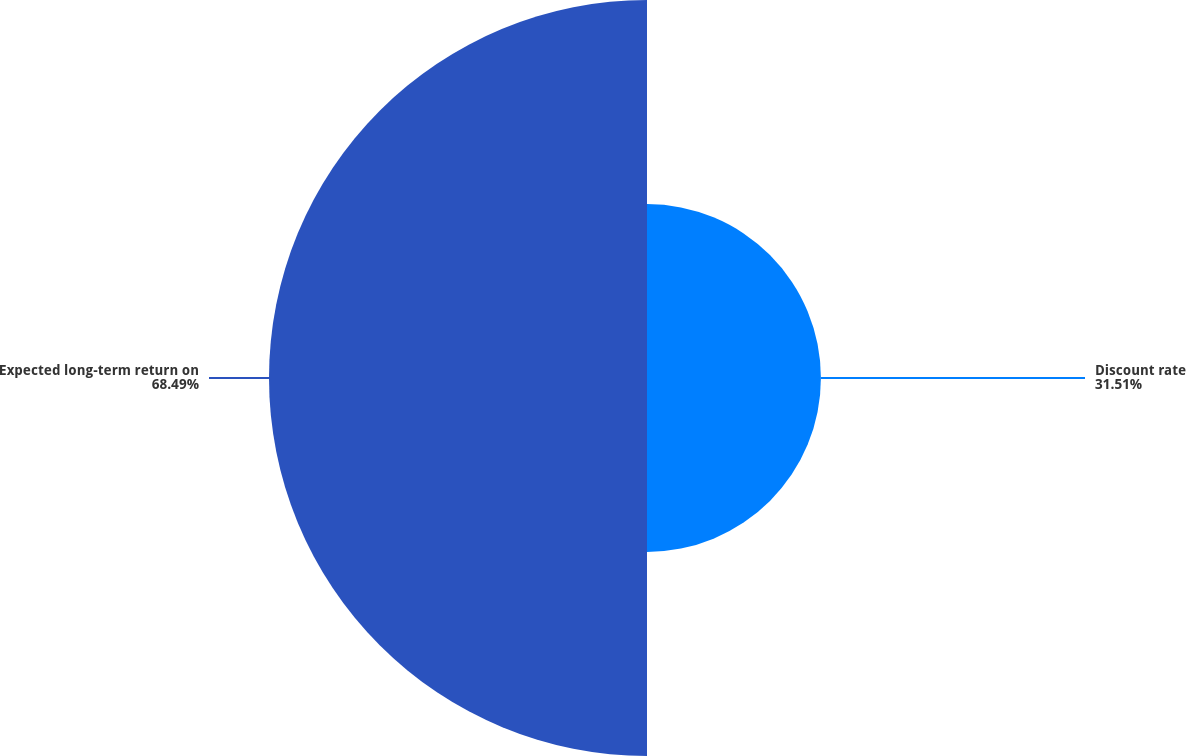<chart> <loc_0><loc_0><loc_500><loc_500><pie_chart><fcel>Discount rate<fcel>Expected long-term return on<nl><fcel>31.51%<fcel>68.49%<nl></chart> 